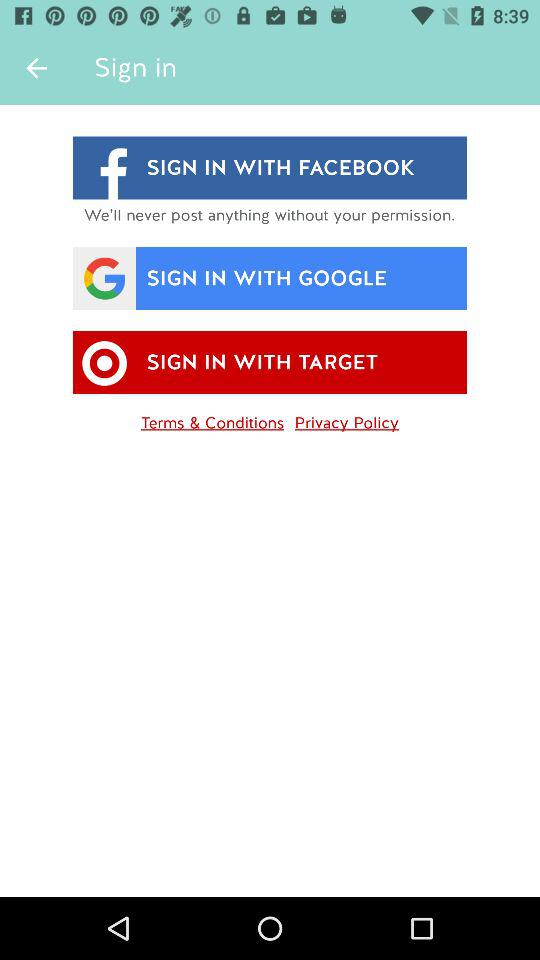What accounts can be used to continue logging in? You can continue logging in with "FACEBOOK", "GOOGLE". and "TARGET". 